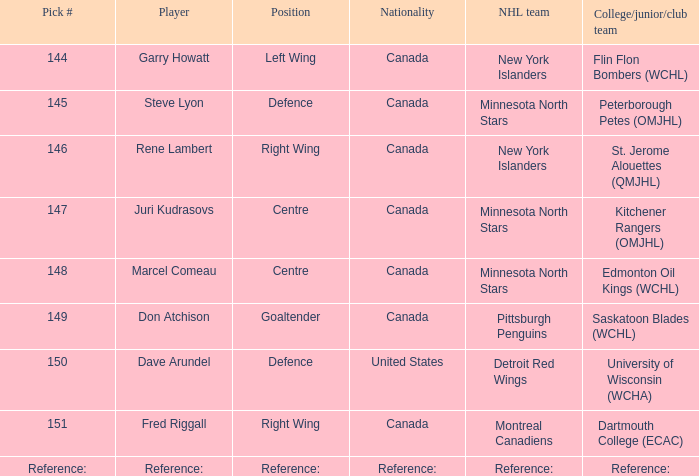Which player(s) was drafted by the Pittsburgh Penguins? Don Atchison. 